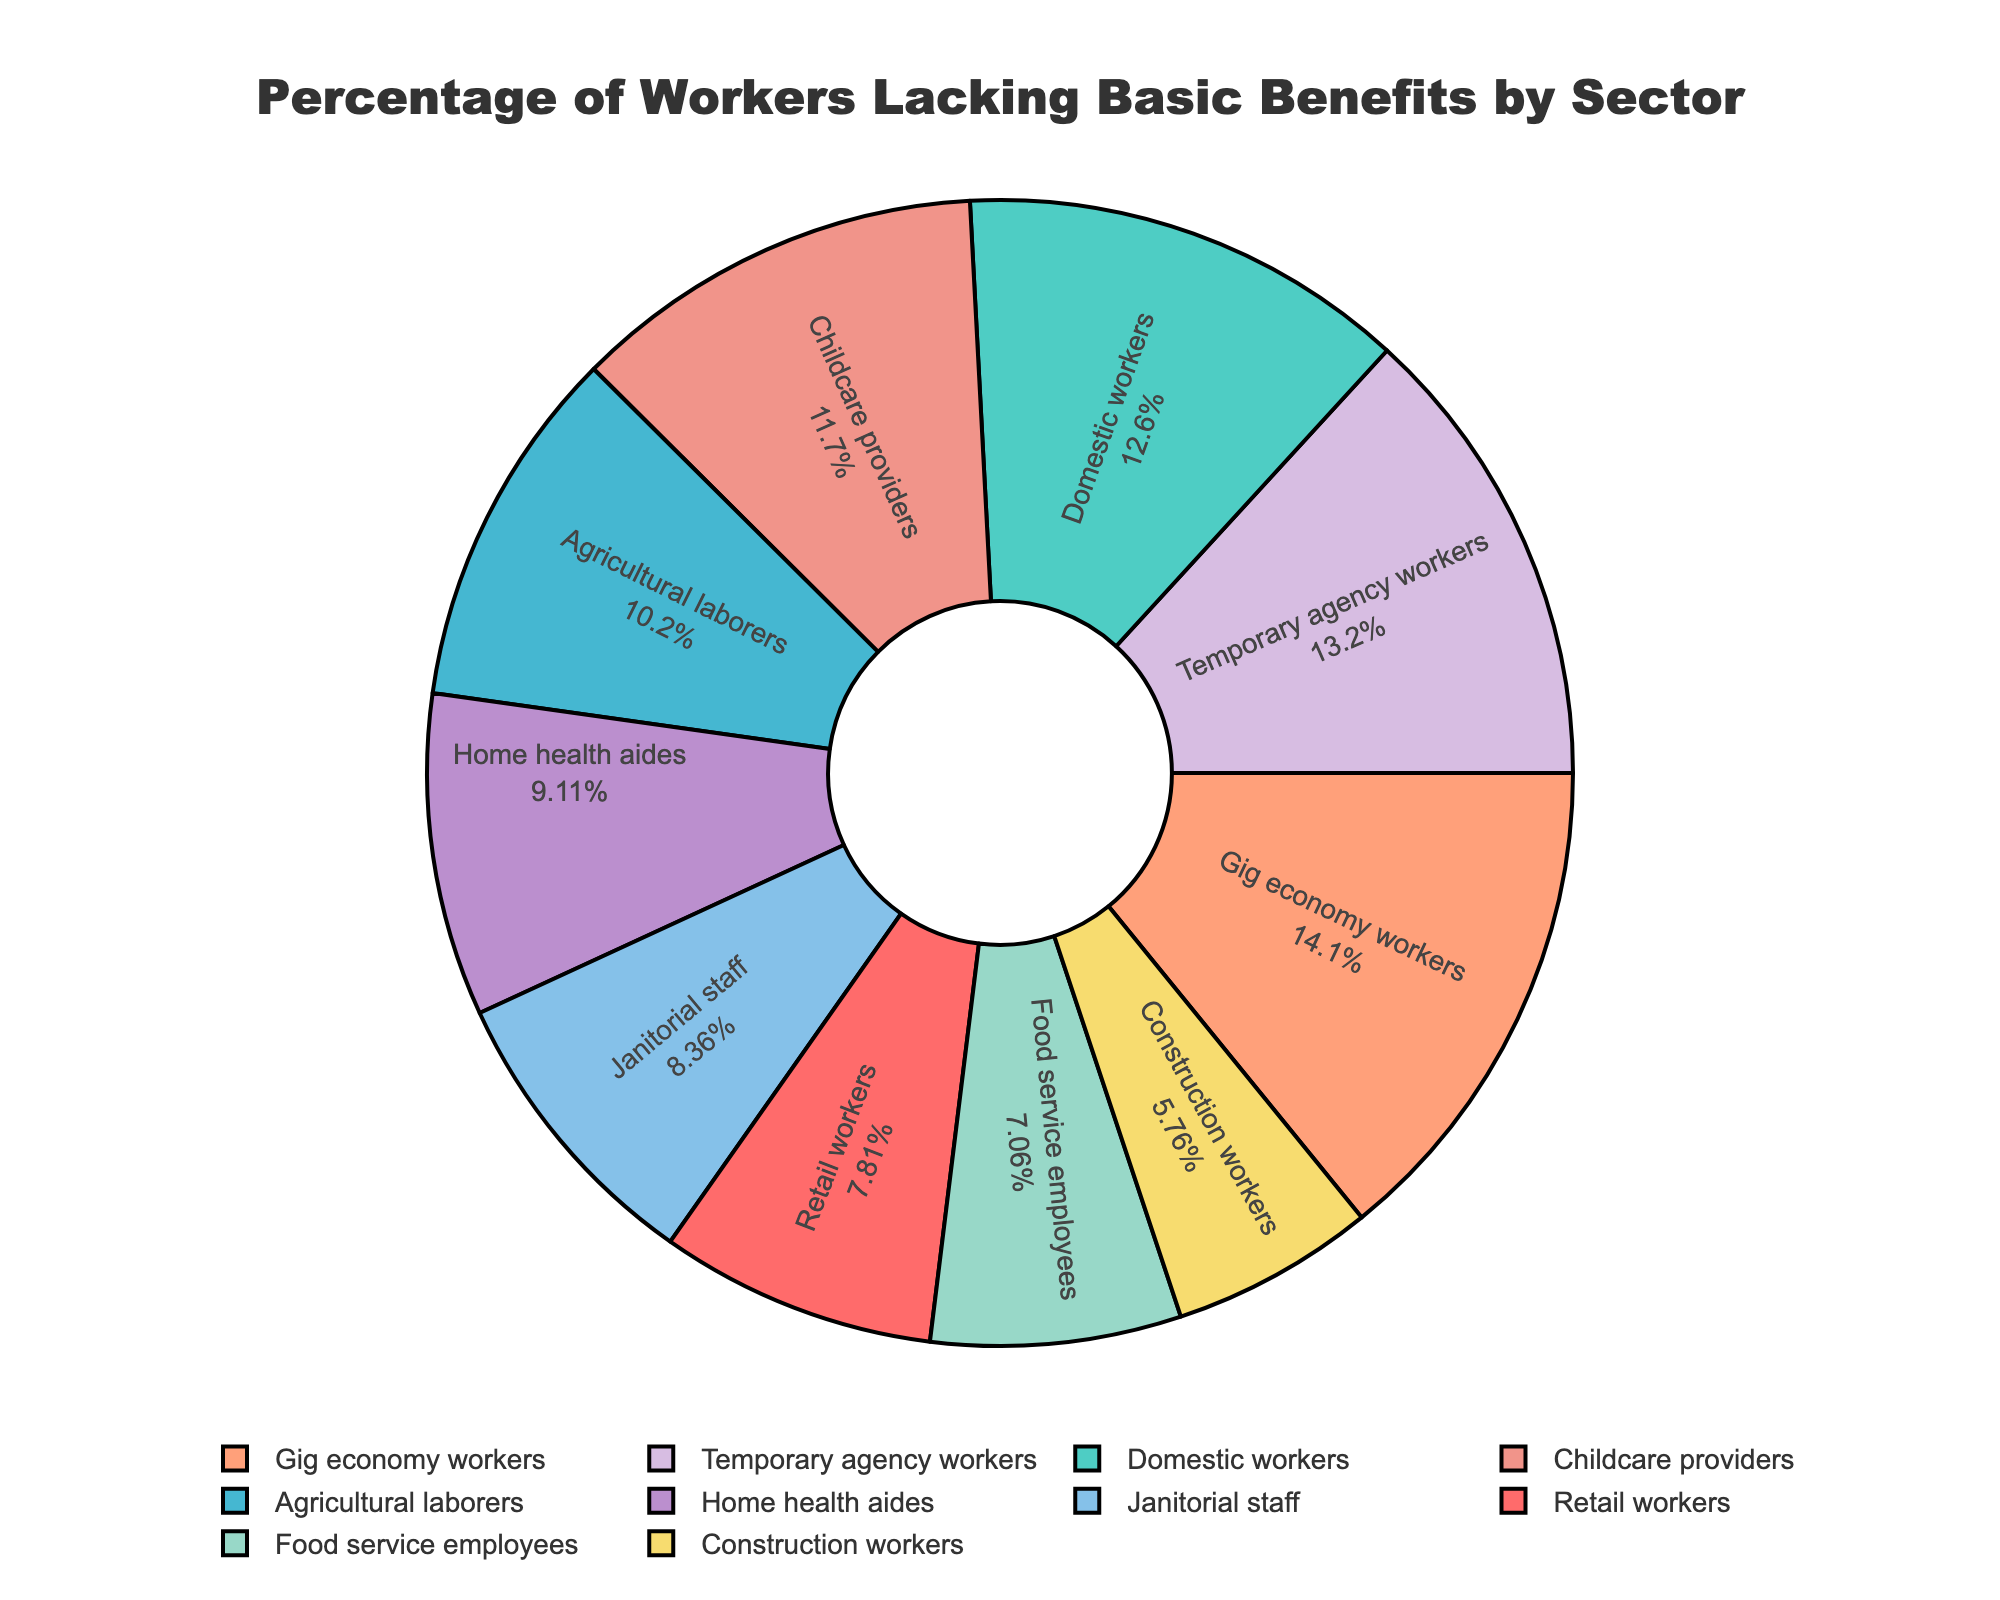Which sector has the highest percentage of workers lacking basic benefits? The gig economy workers have the highest percentage, indicated by the largest segment in the pie chart.
Answer: Gig economy workers Which sector has a lower percentage of workers lacking basic benefits: Home health aides or Food service employees? Food service employees have a lower percentage (38%) compared to home health aides (49%).
Answer: Food service employees How much higher is the percentage of temporary agency workers lacking basic benefits compared to construction workers? Temporary agency workers lack benefits at 71%, while construction workers are at 31%. The difference is 71% - 31% = 40%.
Answer: 40% What is the sum of the percentages of workers lacking basic benefits for the top three sectors? The top three sectors are Gig economy workers (76%), Temporary agency workers (71%), and Domestic workers (68%). Calculating the sum: 76% + 71% + 68% = 215%.
Answer: 215% Which sectors have more than 50% of workers lacking basic benefits? The sectors with more than 50% are Domestic workers (68%), Agricultural laborers (55%), Gig economy workers (76%), Childcare providers (63%), and Temporary agency workers (71%).
Answer: Domestic workers, Agricultural laborers, Gig economy workers, Childcare providers, Temporary agency workers What is the average percentage of workers lacking basic benefits across all sectors? Adding all percentages: 42 + 68 + 55 + 76 + 38 + 31 + 49 + 63 + 45 + 71 = 538. Dividing by the number of sectors (10): 538 / 10 = 53.8%.
Answer: 53.8% Which sector has the smallest percentage of workers lacking basic benefits, and what percentage is that? Construction workers have the smallest percentage, indicated by the smallest segment in the pie chart, at 31%.
Answer: Construction workers, 31% Are there more sectors with less than or more than 50% of workers lacking basic benefits? Counting sectors: Less than 50%: Retail workers, Food service employees, Construction workers, Home health aides, Janitorial staff (5 sectors). More than 50%: Domestic workers, Agricultural laborers, Gig economy workers, Childcare providers, Temporary agency workers (5 sectors).
Answer: Equal number 